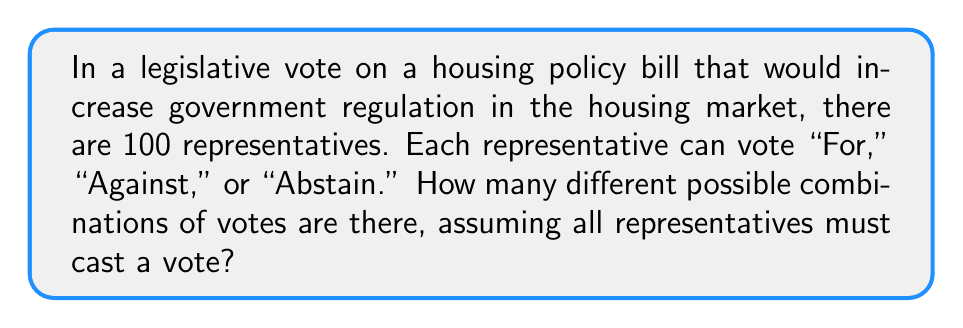Can you solve this math problem? Let's approach this step-by-step:

1) We have 100 representatives, each with 3 choices: "For," "Against," or "Abstain."

2) This is a classic example of the multiplication principle in combinatorics. For each representative, we have 3 independent choices.

3) Since the choices for each representative are independent, we multiply the number of choices for each representative:

   $$3 \times 3 \times 3 \times ... \text{ (100 times)} = 3^{100}$$

4) This can be written as:

   $$\text{Total combinations} = 3^{100}$$

5) To give an idea of the magnitude of this number:
   
   $$3^{100} \approx 5.15 \times 10^{47}$$

This immense number of possibilities demonstrates the complexity of legislative decision-making, even without considering the nuances of individual representatives' positions or the potential influence of government intervention in the housing market.
Answer: $3^{100}$ 